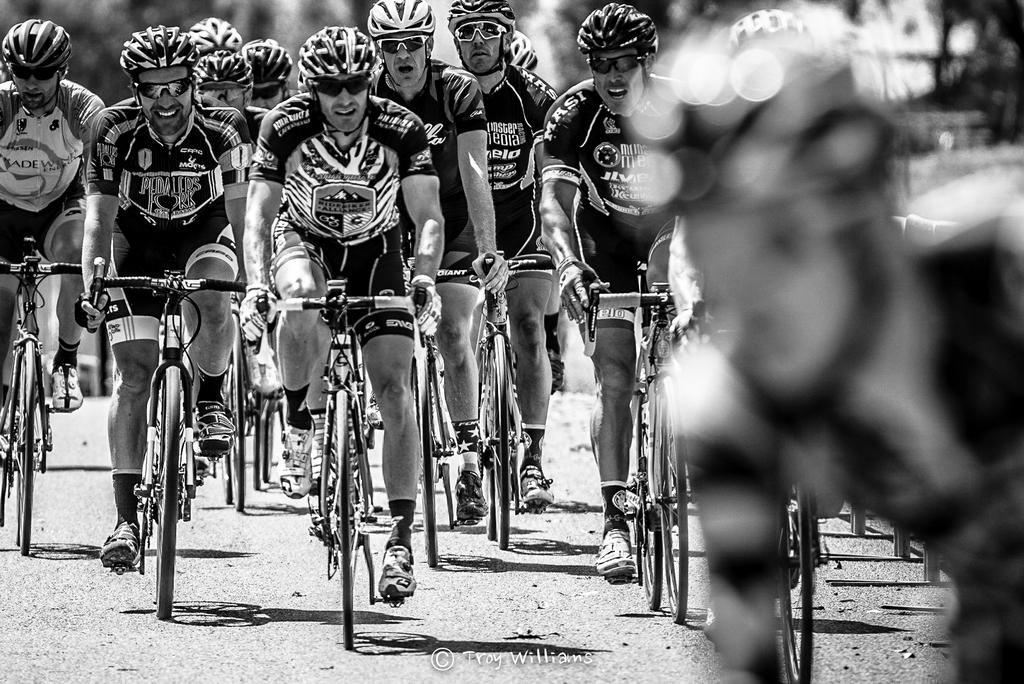What are the people in the image doing? The people in the image are riding bicycles. What safety precautions are the people taking while riding bicycles? The people are wearing helmets. What additional accessory can be seen on the people in the image? The people are wearing shades. What type of grain is being harvested by the people in the image? There is no grain or harvesting activity present in the image; the people are riding bicycles. 